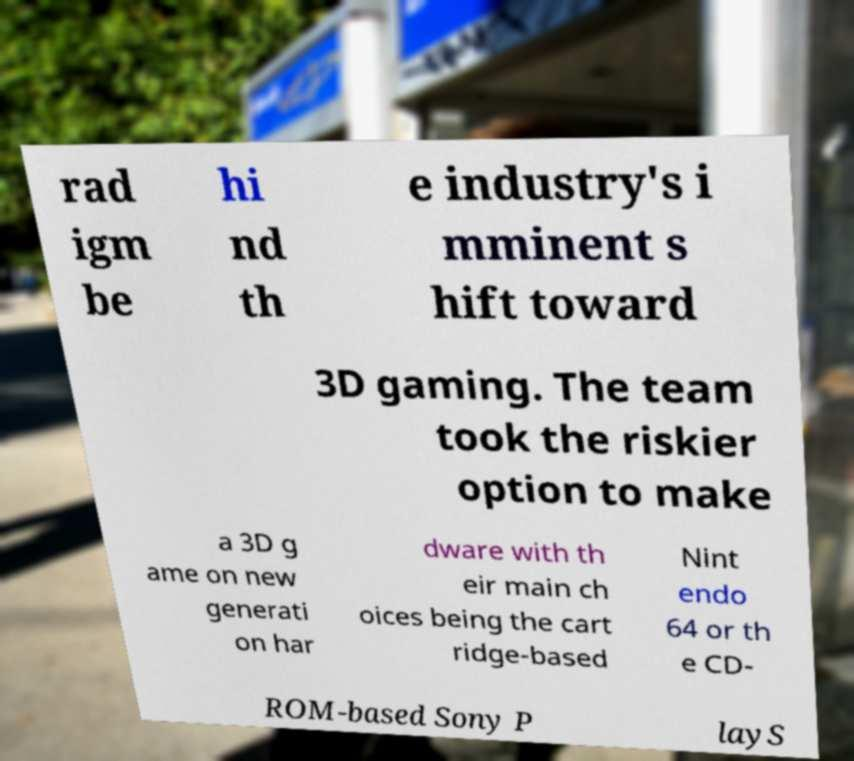Could you assist in decoding the text presented in this image and type it out clearly? rad igm be hi nd th e industry's i mminent s hift toward 3D gaming. The team took the riskier option to make a 3D g ame on new generati on har dware with th eir main ch oices being the cart ridge-based Nint endo 64 or th e CD- ROM-based Sony P layS 